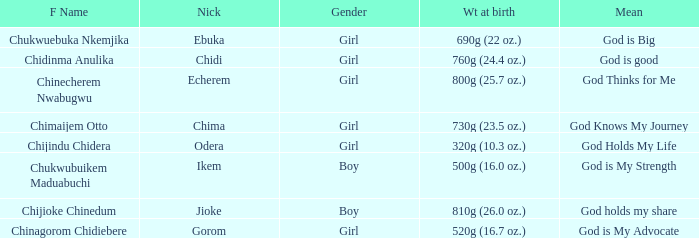Chukwubuikem Maduabuchi is what gender? Boy. 